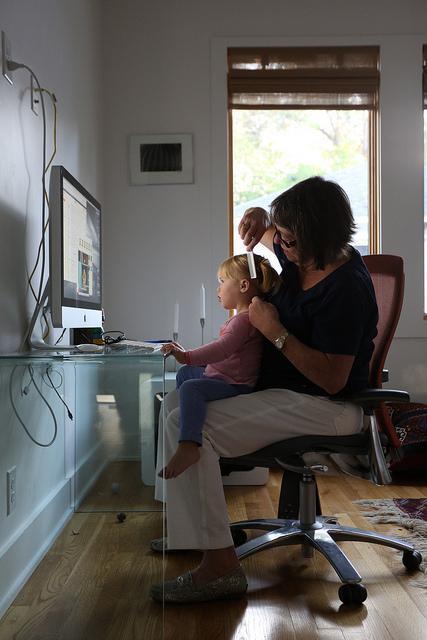How many people are visible?
Give a very brief answer. 2. 